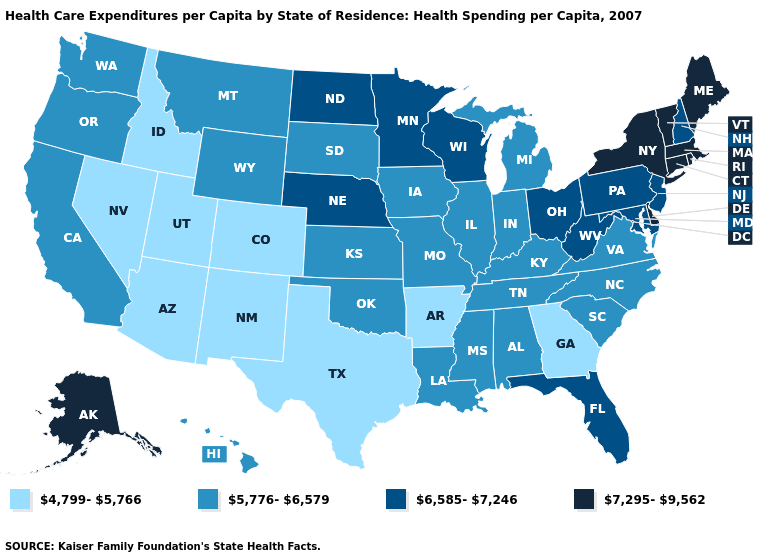Does Michigan have the lowest value in the USA?
Keep it brief. No. What is the highest value in the Northeast ?
Keep it brief. 7,295-9,562. Name the states that have a value in the range 4,799-5,766?
Be succinct. Arizona, Arkansas, Colorado, Georgia, Idaho, Nevada, New Mexico, Texas, Utah. What is the value of Montana?
Keep it brief. 5,776-6,579. Does Massachusetts have a lower value than Georgia?
Concise answer only. No. Name the states that have a value in the range 7,295-9,562?
Short answer required. Alaska, Connecticut, Delaware, Maine, Massachusetts, New York, Rhode Island, Vermont. Does Illinois have the highest value in the USA?
Quick response, please. No. Name the states that have a value in the range 7,295-9,562?
Short answer required. Alaska, Connecticut, Delaware, Maine, Massachusetts, New York, Rhode Island, Vermont. What is the value of Delaware?
Keep it brief. 7,295-9,562. What is the value of Pennsylvania?
Short answer required. 6,585-7,246. Among the states that border Kentucky , which have the highest value?
Be succinct. Ohio, West Virginia. Name the states that have a value in the range 5,776-6,579?
Concise answer only. Alabama, California, Hawaii, Illinois, Indiana, Iowa, Kansas, Kentucky, Louisiana, Michigan, Mississippi, Missouri, Montana, North Carolina, Oklahoma, Oregon, South Carolina, South Dakota, Tennessee, Virginia, Washington, Wyoming. Name the states that have a value in the range 7,295-9,562?
Give a very brief answer. Alaska, Connecticut, Delaware, Maine, Massachusetts, New York, Rhode Island, Vermont. What is the value of Nebraska?
Short answer required. 6,585-7,246. 